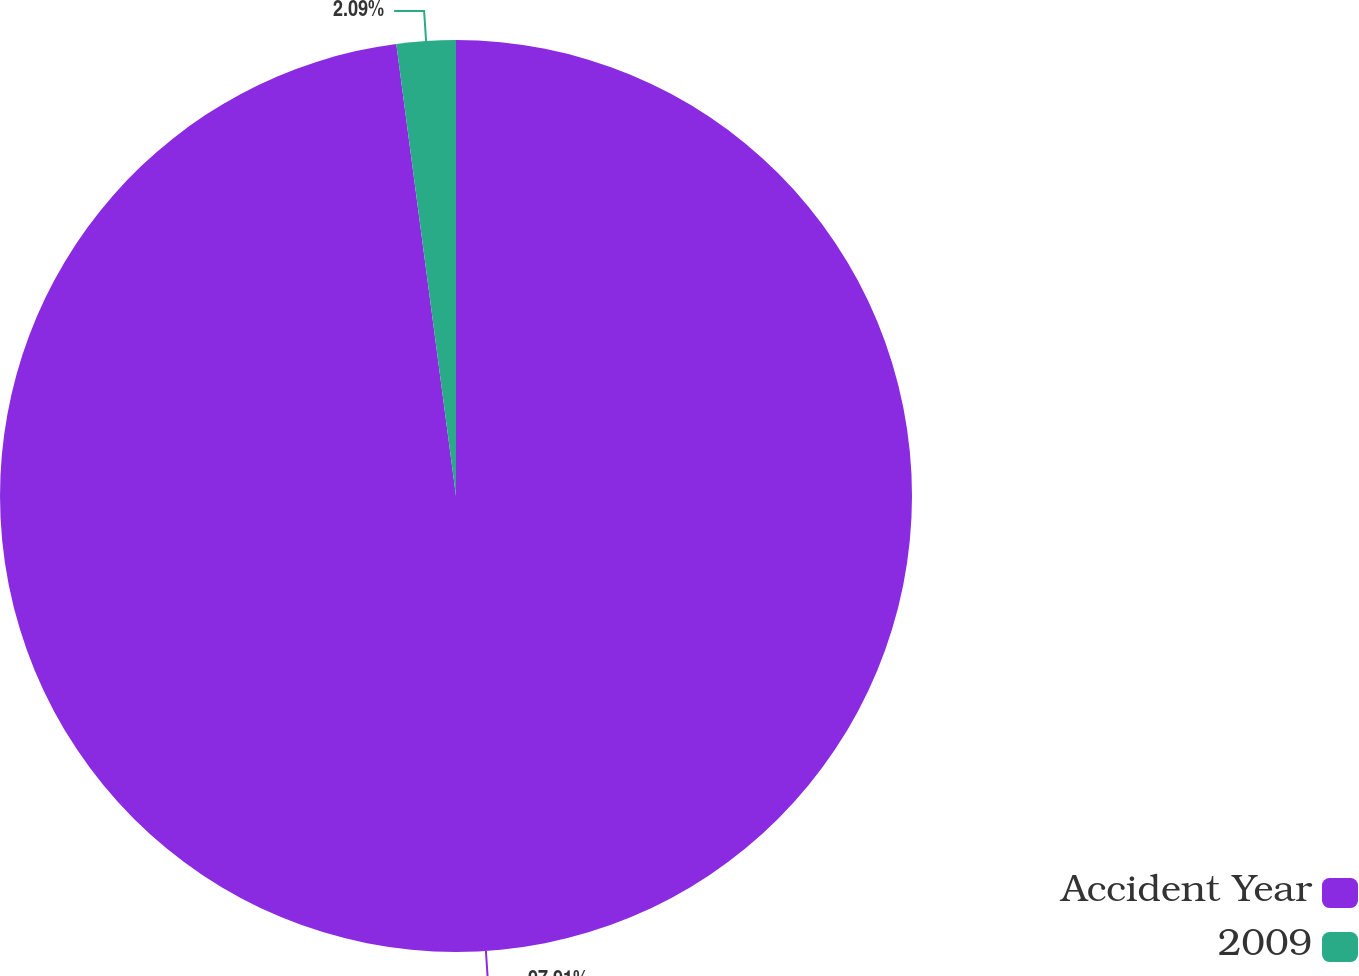Convert chart. <chart><loc_0><loc_0><loc_500><loc_500><pie_chart><fcel>Accident Year<fcel>2009<nl><fcel>97.91%<fcel>2.09%<nl></chart> 